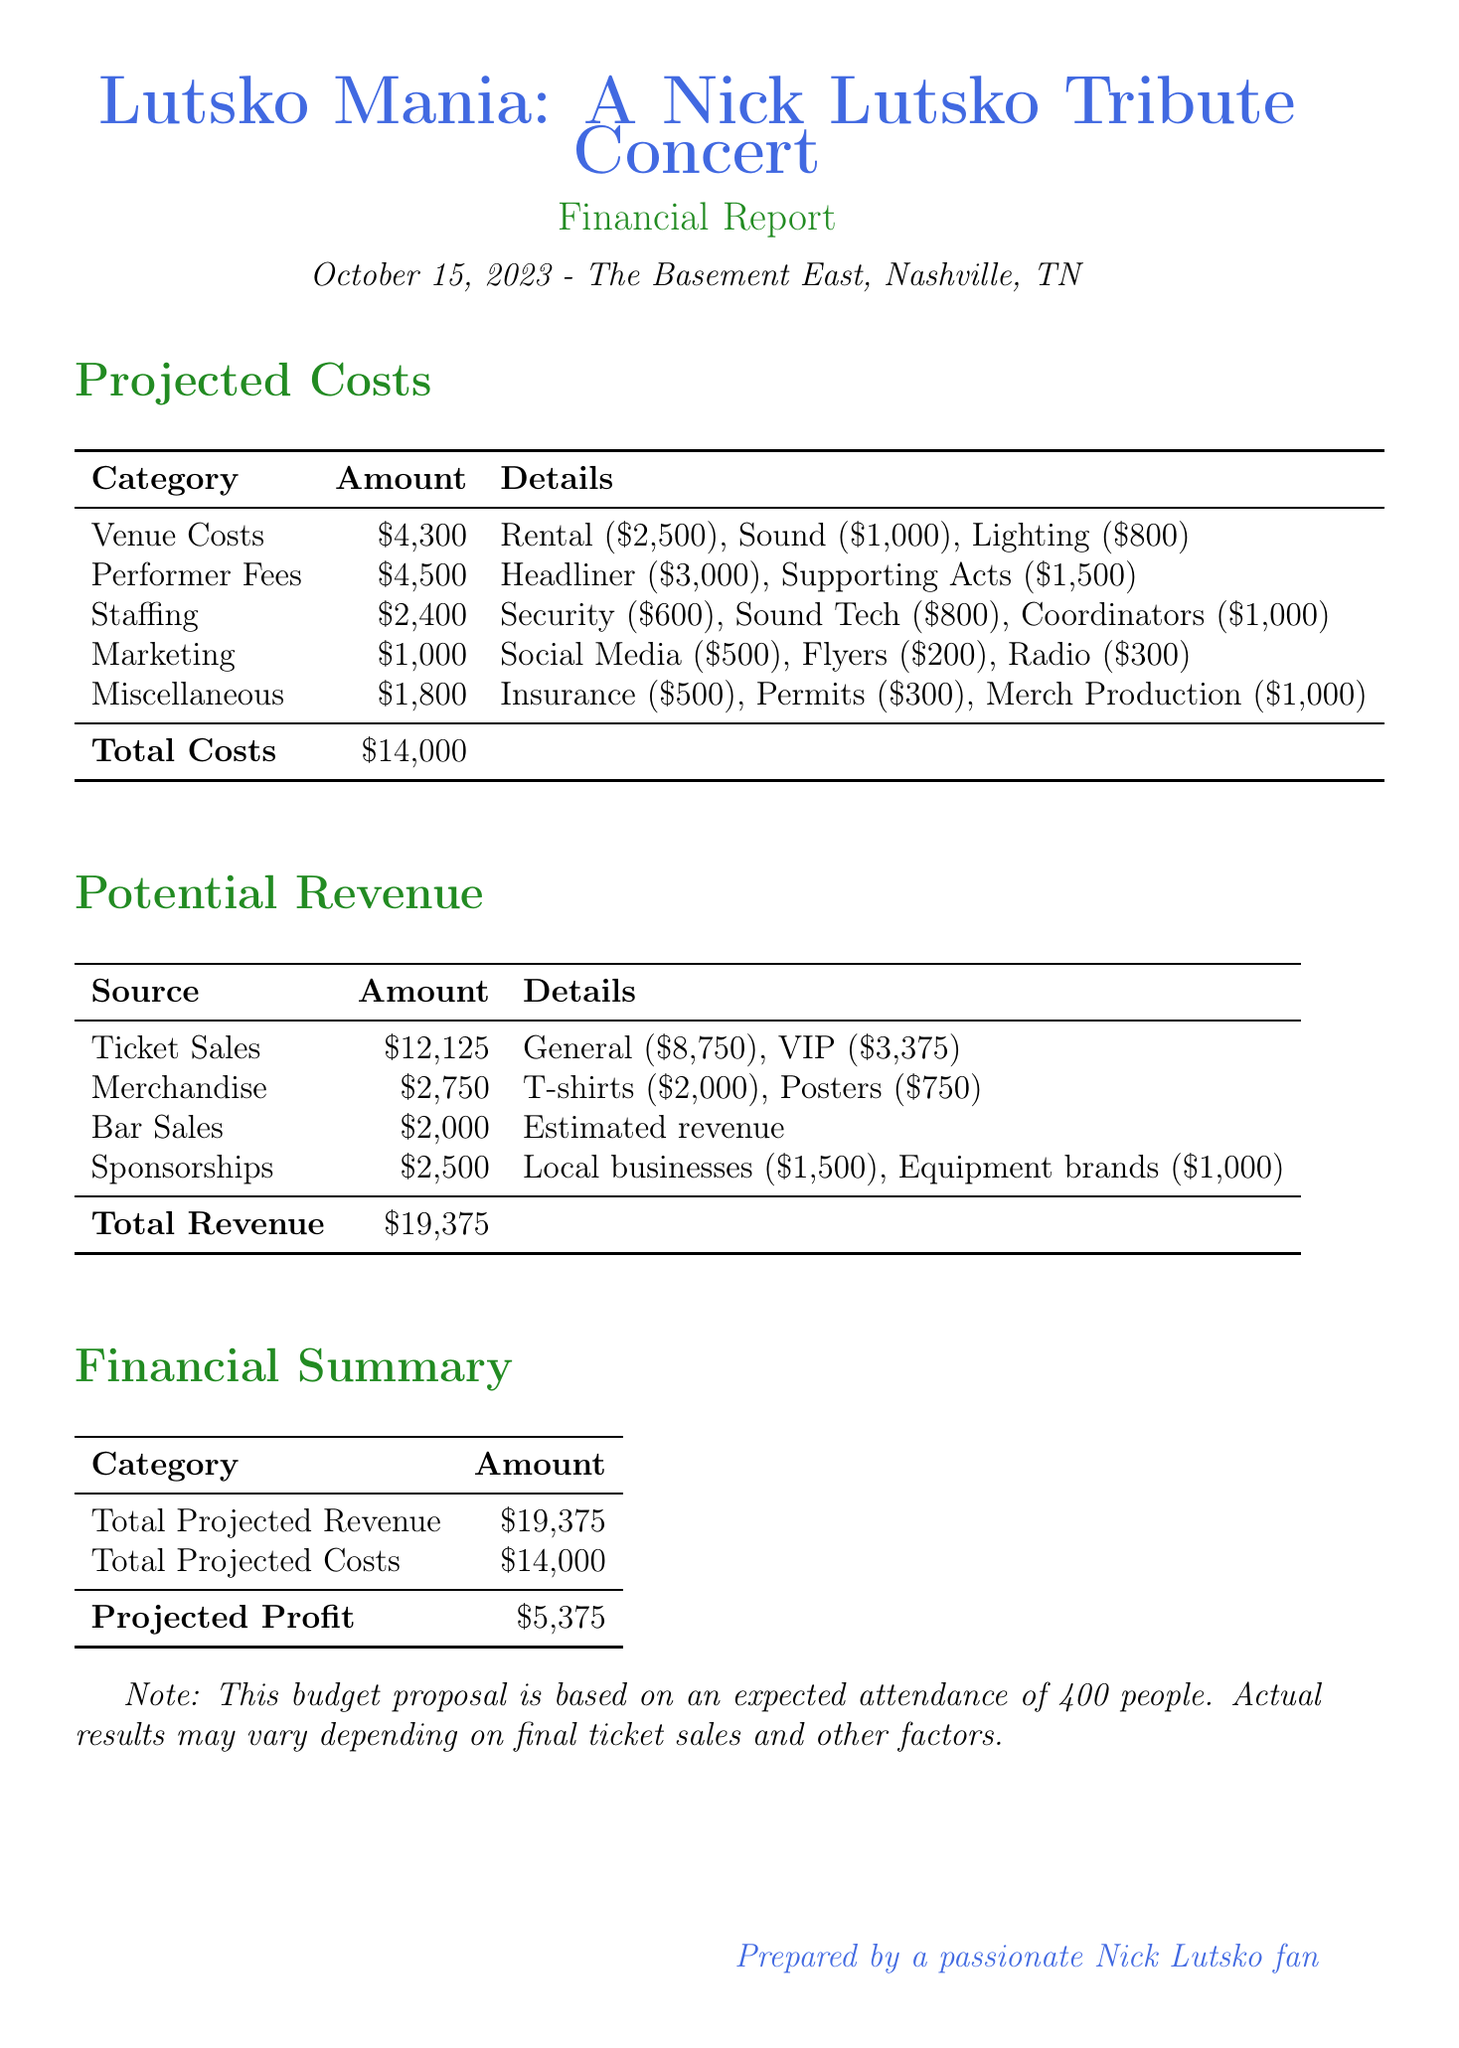what is the date of the concert? The date of the concert is specified in the event details section of the document.
Answer: October 15, 2023 what is the venue of the concert? The venue is mentioned in the event details section, indicating where the concert will take place.
Answer: The Basement East, Nashville, TN how much is allocated for performer fees? Performer fees are detailed in the projected costs section, providing a breakdown of costs for the headlining and supporting acts.
Answer: $4,500 what is the estimated revenue from merchandise sales? The estimated revenue from merchandise is specified in the potential revenue section, showing the expected earnings from T-shirts and posters.
Answer: $2,750 what is the total projected profit? The total projected profit is calculated by subtracting total projected costs from total projected revenue, as summarized in the financial summary section.
Answer: $5,375 how many general admission tickets are anticipated to be sold? The document provides information about ticket sales, including the quantity of general admission tickets and their price.
Answer: 350 what is the cost for security personnel? The cost for security personnel is part of the staffing projected costs and is listed in the document.
Answer: $600 what is the total cost for venue-related expenses? The total cost for venue-related expenses includes rental, sound equipment, and lighting costs, as detailed in the projected costs section.
Answer: $4,300 how much are expected bar sales revenue? The expected revenue from bar sales is mentioned clearly in the potential revenue section of the report.
Answer: $2,000 